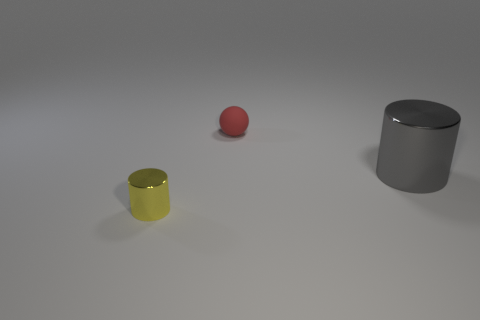Add 1 gray cylinders. How many objects exist? 4 Subtract all cylinders. How many objects are left? 1 Subtract all small matte balls. Subtract all cyan matte spheres. How many objects are left? 2 Add 3 gray shiny things. How many gray shiny things are left? 4 Add 3 matte balls. How many matte balls exist? 4 Subtract 1 yellow cylinders. How many objects are left? 2 